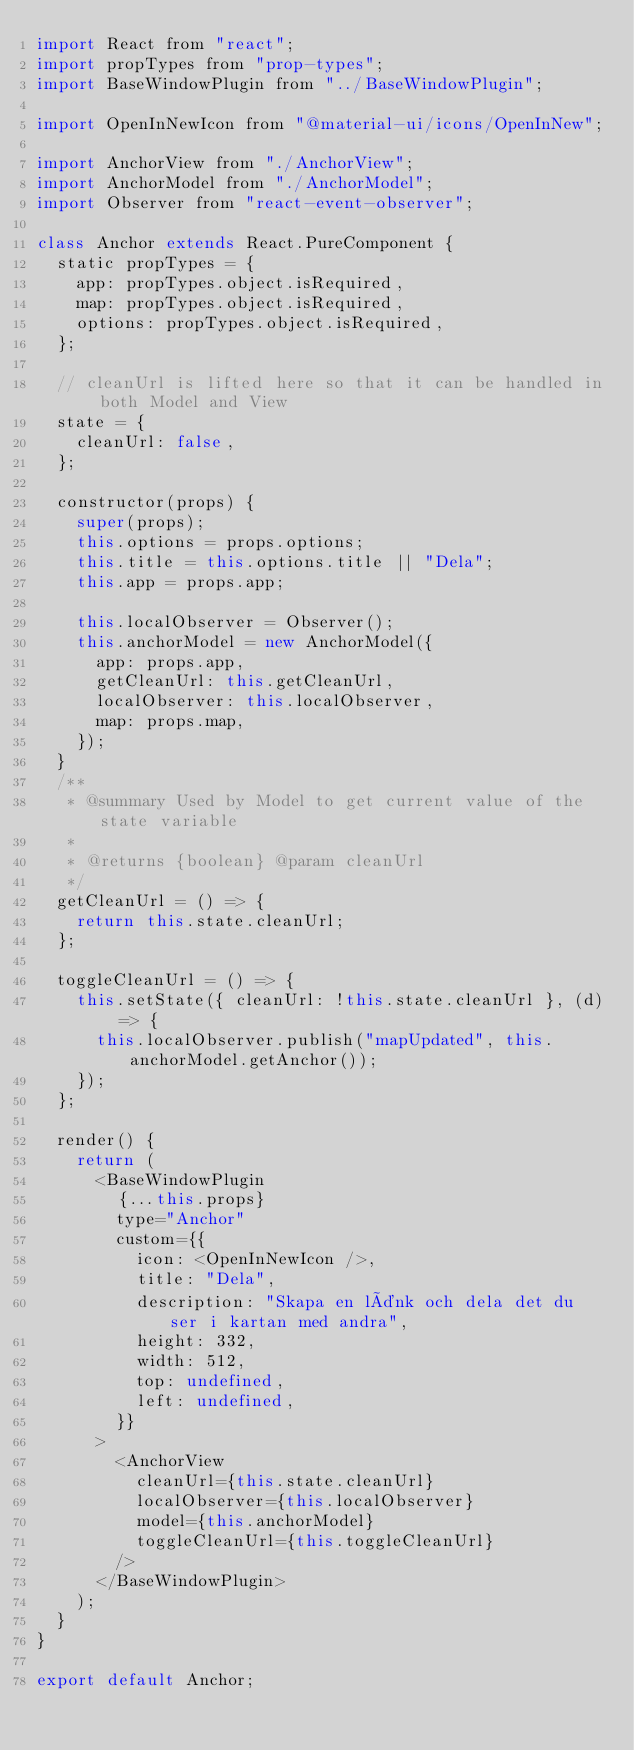Convert code to text. <code><loc_0><loc_0><loc_500><loc_500><_JavaScript_>import React from "react";
import propTypes from "prop-types";
import BaseWindowPlugin from "../BaseWindowPlugin";

import OpenInNewIcon from "@material-ui/icons/OpenInNew";

import AnchorView from "./AnchorView";
import AnchorModel from "./AnchorModel";
import Observer from "react-event-observer";

class Anchor extends React.PureComponent {
  static propTypes = {
    app: propTypes.object.isRequired,
    map: propTypes.object.isRequired,
    options: propTypes.object.isRequired,
  };

  // cleanUrl is lifted here so that it can be handled in both Model and View
  state = {
    cleanUrl: false,
  };

  constructor(props) {
    super(props);
    this.options = props.options;
    this.title = this.options.title || "Dela";
    this.app = props.app;

    this.localObserver = Observer();
    this.anchorModel = new AnchorModel({
      app: props.app,
      getCleanUrl: this.getCleanUrl,
      localObserver: this.localObserver,
      map: props.map,
    });
  }
  /**
   * @summary Used by Model to get current value of the state variable
   *
   * @returns {boolean} @param cleanUrl
   */
  getCleanUrl = () => {
    return this.state.cleanUrl;
  };

  toggleCleanUrl = () => {
    this.setState({ cleanUrl: !this.state.cleanUrl }, (d) => {
      this.localObserver.publish("mapUpdated", this.anchorModel.getAnchor());
    });
  };

  render() {
    return (
      <BaseWindowPlugin
        {...this.props}
        type="Anchor"
        custom={{
          icon: <OpenInNewIcon />,
          title: "Dela",
          description: "Skapa en länk och dela det du ser i kartan med andra",
          height: 332,
          width: 512,
          top: undefined,
          left: undefined,
        }}
      >
        <AnchorView
          cleanUrl={this.state.cleanUrl}
          localObserver={this.localObserver}
          model={this.anchorModel}
          toggleCleanUrl={this.toggleCleanUrl}
        />
      </BaseWindowPlugin>
    );
  }
}

export default Anchor;
</code> 